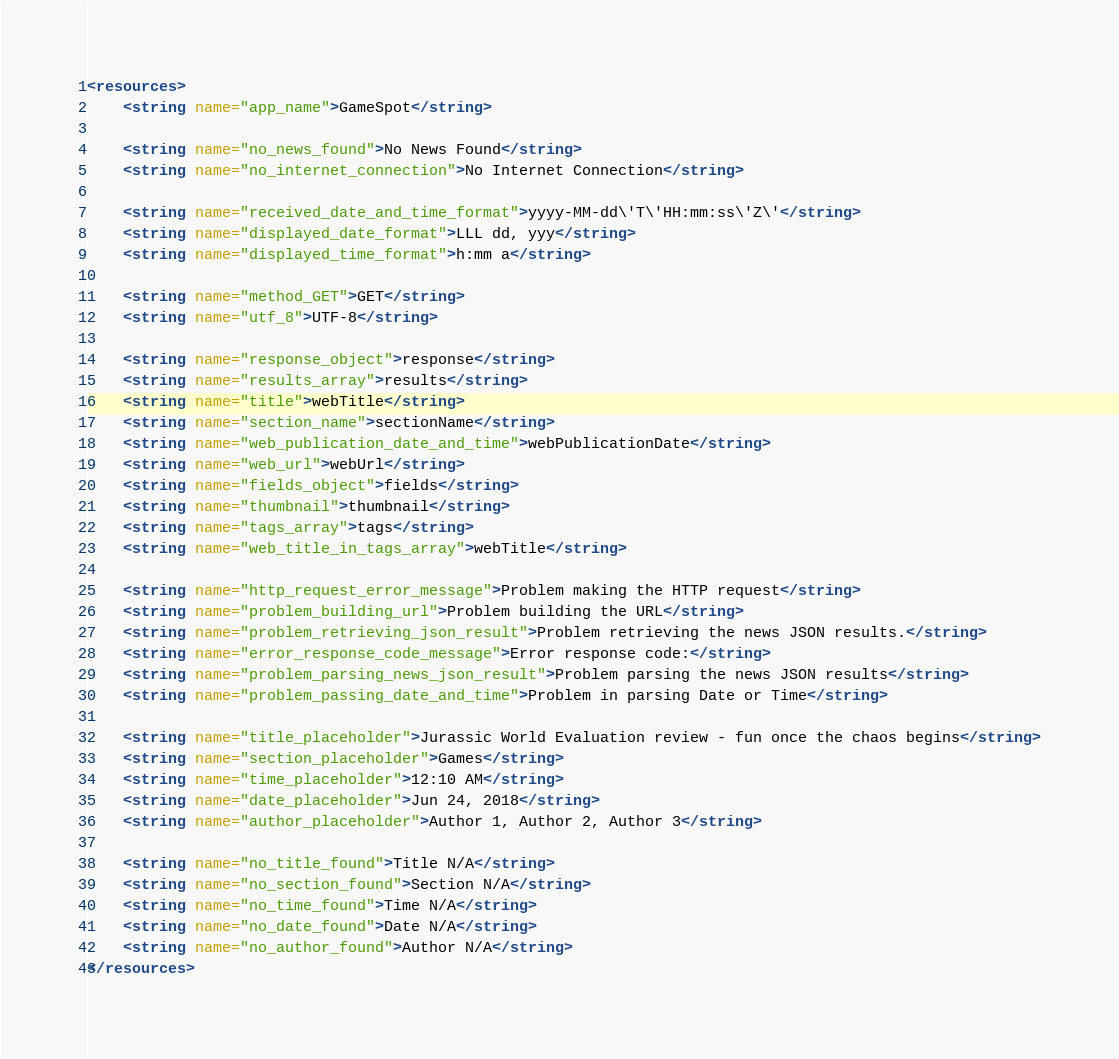Convert code to text. <code><loc_0><loc_0><loc_500><loc_500><_XML_><resources>
    <string name="app_name">GameSpot</string>

    <string name="no_news_found">No News Found</string>
    <string name="no_internet_connection">No Internet Connection</string>

    <string name="received_date_and_time_format">yyyy-MM-dd\'T\'HH:mm:ss\'Z\'</string>
    <string name="displayed_date_format">LLL dd, yyy</string>
    <string name="displayed_time_format">h:mm a</string>

    <string name="method_GET">GET</string>
    <string name="utf_8">UTF-8</string>

    <string name="response_object">response</string>
    <string name="results_array">results</string>
    <string name="title">webTitle</string>
    <string name="section_name">sectionName</string>
    <string name="web_publication_date_and_time">webPublicationDate</string>
    <string name="web_url">webUrl</string>
    <string name="fields_object">fields</string>
    <string name="thumbnail">thumbnail</string>
    <string name="tags_array">tags</string>
    <string name="web_title_in_tags_array">webTitle</string>

    <string name="http_request_error_message">Problem making the HTTP request</string>
    <string name="problem_building_url">Problem building the URL</string>
    <string name="problem_retrieving_json_result">Problem retrieving the news JSON results.</string>
    <string name="error_response_code_message">Error response code:</string>
    <string name="problem_parsing_news_json_result">Problem parsing the news JSON results</string>
    <string name="problem_passing_date_and_time">Problem in parsing Date or Time</string>

    <string name="title_placeholder">Jurassic World Evaluation review - fun once the chaos begins</string>
    <string name="section_placeholder">Games</string>
    <string name="time_placeholder">12:10 AM</string>
    <string name="date_placeholder">Jun 24, 2018</string>
    <string name="author_placeholder">Author 1, Author 2, Author 3</string>

    <string name="no_title_found">Title N/A</string>
    <string name="no_section_found">Section N/A</string>
    <string name="no_time_found">Time N/A</string>
    <string name="no_date_found">Date N/A</string>
    <string name="no_author_found">Author N/A</string>
</resources>
</code> 